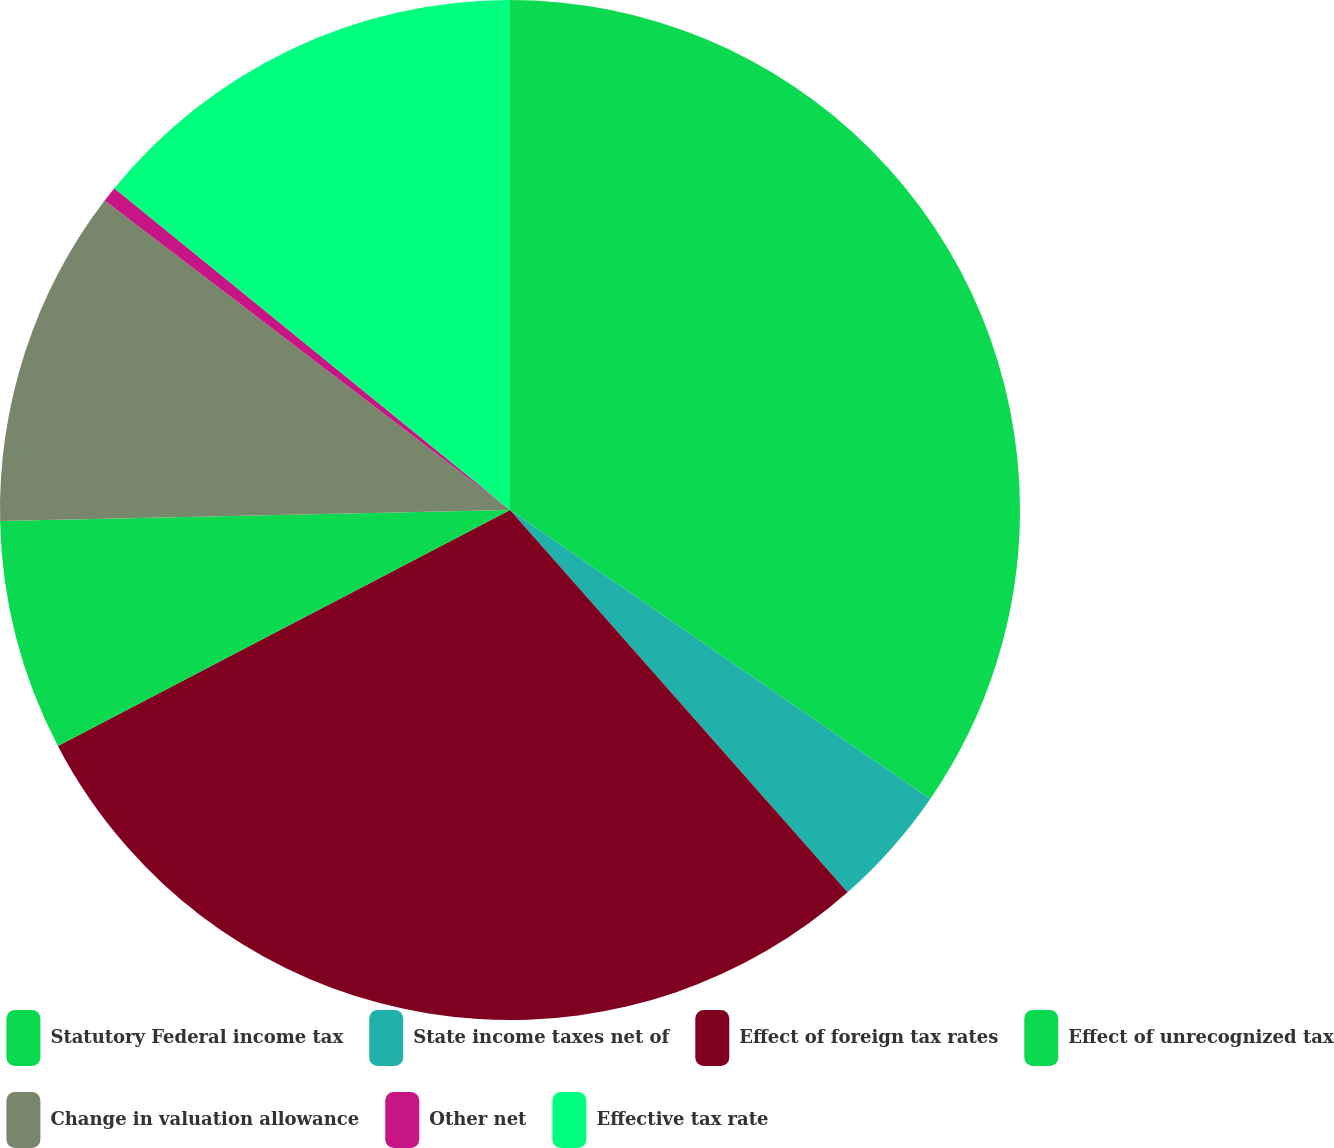<chart> <loc_0><loc_0><loc_500><loc_500><pie_chart><fcel>Statutory Federal income tax<fcel>State income taxes net of<fcel>Effect of foreign tax rates<fcel>Effect of unrecognized tax<fcel>Change in valuation allowance<fcel>Other net<fcel>Effective tax rate<nl><fcel>34.58%<fcel>3.9%<fcel>28.85%<fcel>7.31%<fcel>10.72%<fcel>0.49%<fcel>14.13%<nl></chart> 